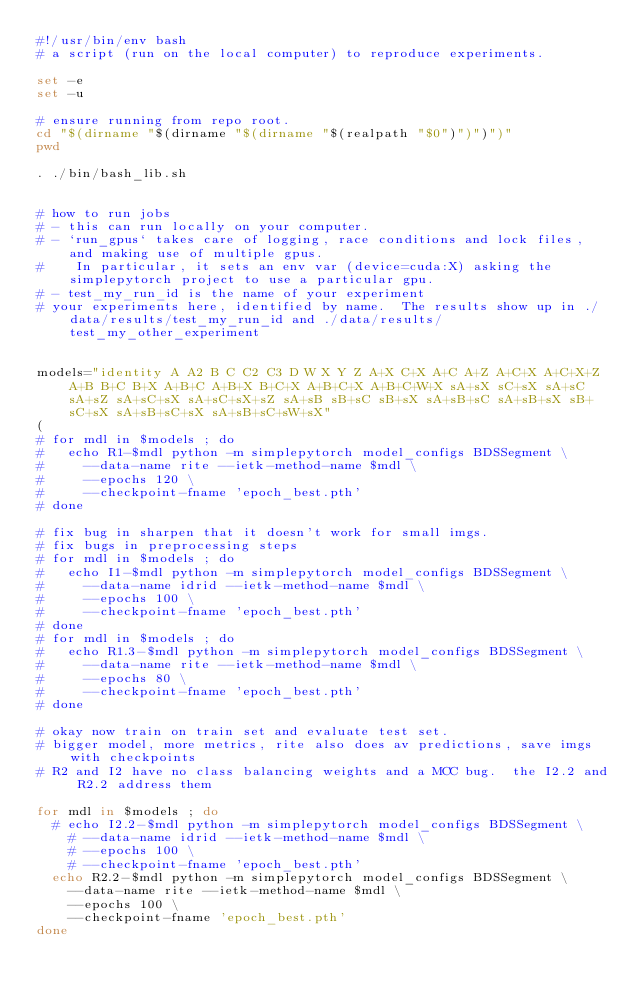Convert code to text. <code><loc_0><loc_0><loc_500><loc_500><_Bash_>#!/usr/bin/env bash
# a script (run on the local computer) to reproduce experiments.

set -e
set -u

# ensure running from repo root.
cd "$(dirname "$(dirname "$(dirname "$(realpath "$0")")")")"
pwd

. ./bin/bash_lib.sh


# how to run jobs
# - this can run locally on your computer.
# - `run_gpus` takes care of logging, race conditions and lock files, and making use of multiple gpus.
#    In particular, it sets an env var (device=cuda:X) asking the simplepytorch project to use a particular gpu.
# - test_my_run_id is the name of your experiment
# your experiments here, identified by name.  The results show up in ./data/results/test_my_run_id and ./data/results/test_my_other_experiment


models="identity A A2 B C C2 C3 D W X Y Z A+X C+X A+C A+Z A+C+X A+C+X+Z A+B B+C B+X A+B+C A+B+X B+C+X A+B+C+X A+B+C+W+X sA+sX sC+sX sA+sC sA+sZ sA+sC+sX sA+sC+sX+sZ sA+sB sB+sC sB+sX sA+sB+sC sA+sB+sX sB+sC+sX sA+sB+sC+sX sA+sB+sC+sW+sX"
(
# for mdl in $models ; do
#   echo R1-$mdl python -m simplepytorch model_configs BDSSegment \
#     --data-name rite --ietk-method-name $mdl \
#     --epochs 120 \
#     --checkpoint-fname 'epoch_best.pth'
# done

# fix bug in sharpen that it doesn't work for small imgs.
# fix bugs in preprocessing steps
# for mdl in $models ; do
#   echo I1-$mdl python -m simplepytorch model_configs BDSSegment \
#     --data-name idrid --ietk-method-name $mdl \
#     --epochs 100 \
#     --checkpoint-fname 'epoch_best.pth'
# done
# for mdl in $models ; do
#   echo R1.3-$mdl python -m simplepytorch model_configs BDSSegment \
#     --data-name rite --ietk-method-name $mdl \
#     --epochs 80 \
#     --checkpoint-fname 'epoch_best.pth'
# done

# okay now train on train set and evaluate test set.
# bigger model, more metrics, rite also does av predictions, save imgs with checkpoints
# R2 and I2 have no class balancing weights and a MCC bug.  the I2.2 and R2.2 address them

for mdl in $models ; do
  # echo I2.2-$mdl python -m simplepytorch model_configs BDSSegment \
    # --data-name idrid --ietk-method-name $mdl \
    # --epochs 100 \
    # --checkpoint-fname 'epoch_best.pth'
  echo R2.2-$mdl python -m simplepytorch model_configs BDSSegment \
    --data-name rite --ietk-method-name $mdl \
    --epochs 100 \
    --checkpoint-fname 'epoch_best.pth'
done
</code> 